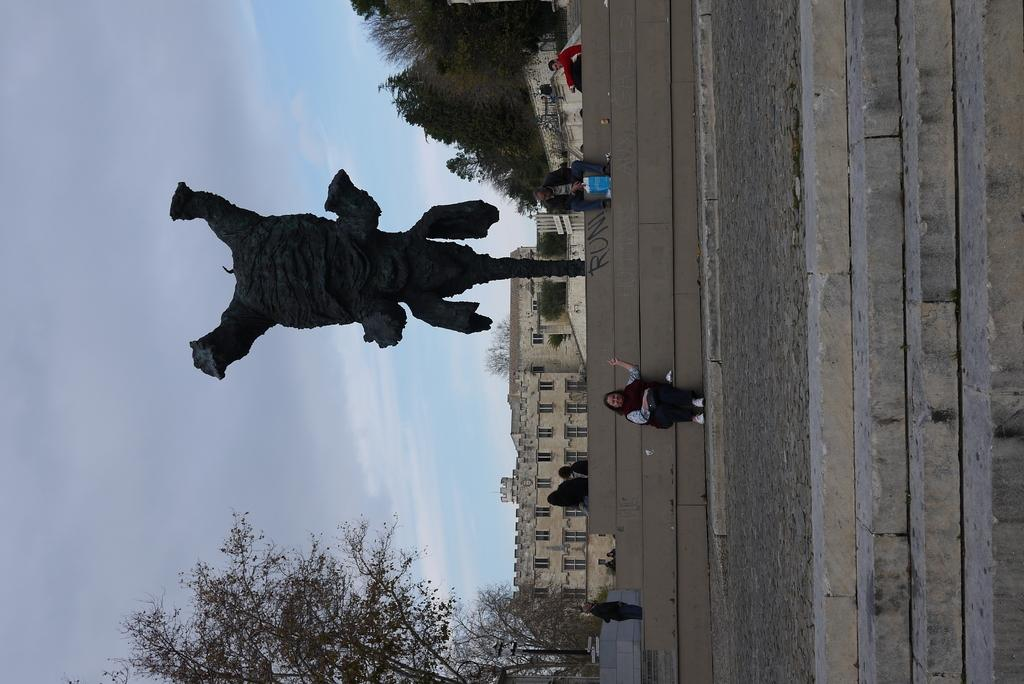What are the people in the image doing? The people in the image are sitting on steps. What else can be seen in the image besides the people? There is a sculpture in the image. What is visible in the background of the image? Trees are visible behind the people and the sculpture. How many chairs are being used by the crows in the image? There are no crows or chairs present in the image. 